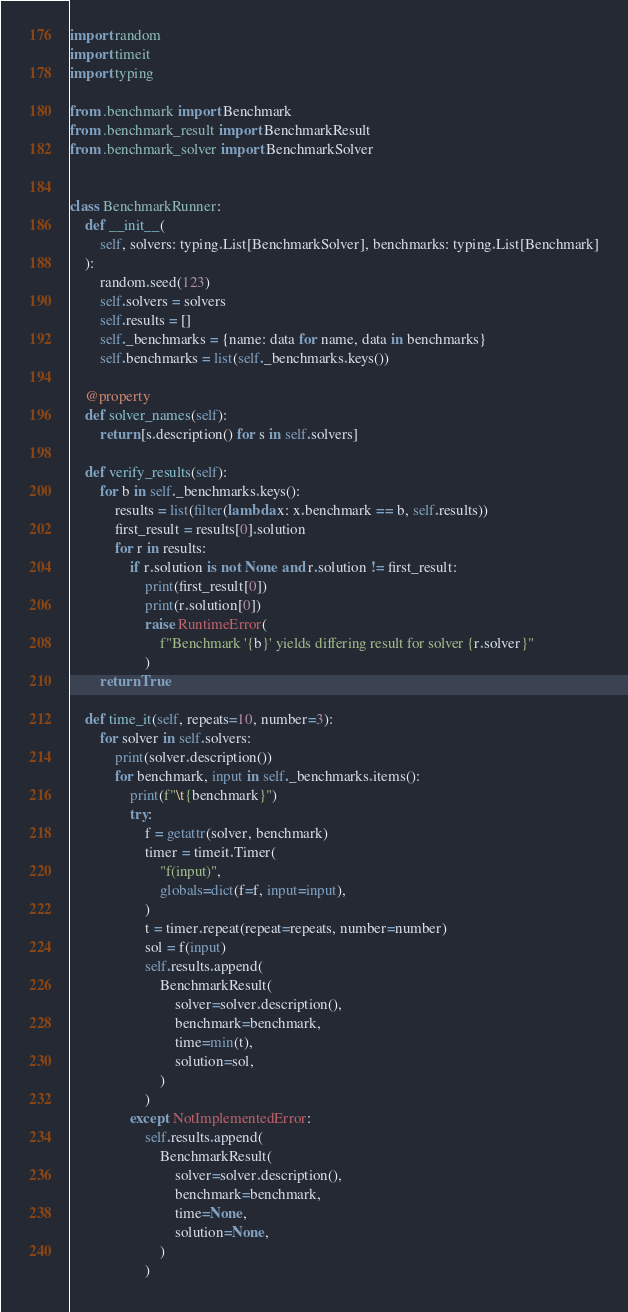<code> <loc_0><loc_0><loc_500><loc_500><_Python_>import random
import timeit
import typing

from .benchmark import Benchmark
from .benchmark_result import BenchmarkResult
from .benchmark_solver import BenchmarkSolver


class BenchmarkRunner:
    def __init__(
        self, solvers: typing.List[BenchmarkSolver], benchmarks: typing.List[Benchmark]
    ):
        random.seed(123)
        self.solvers = solvers
        self.results = []
        self._benchmarks = {name: data for name, data in benchmarks}
        self.benchmarks = list(self._benchmarks.keys())

    @property
    def solver_names(self):
        return [s.description() for s in self.solvers]

    def verify_results(self):
        for b in self._benchmarks.keys():
            results = list(filter(lambda x: x.benchmark == b, self.results))
            first_result = results[0].solution
            for r in results:
                if r.solution is not None and r.solution != first_result:
                    print(first_result[0])
                    print(r.solution[0])
                    raise RuntimeError(
                        f"Benchmark '{b}' yields differing result for solver {r.solver}"
                    )
        return True

    def time_it(self, repeats=10, number=3):
        for solver in self.solvers:
            print(solver.description())
            for benchmark, input in self._benchmarks.items():
                print(f"\t{benchmark}")
                try:
                    f = getattr(solver, benchmark)
                    timer = timeit.Timer(
                        "f(input)",
                        globals=dict(f=f, input=input),
                    )
                    t = timer.repeat(repeat=repeats, number=number)
                    sol = f(input)
                    self.results.append(
                        BenchmarkResult(
                            solver=solver.description(),
                            benchmark=benchmark,
                            time=min(t),
                            solution=sol,
                        )
                    )
                except NotImplementedError:
                    self.results.append(
                        BenchmarkResult(
                            solver=solver.description(),
                            benchmark=benchmark,
                            time=None,
                            solution=None,
                        )
                    )
</code> 